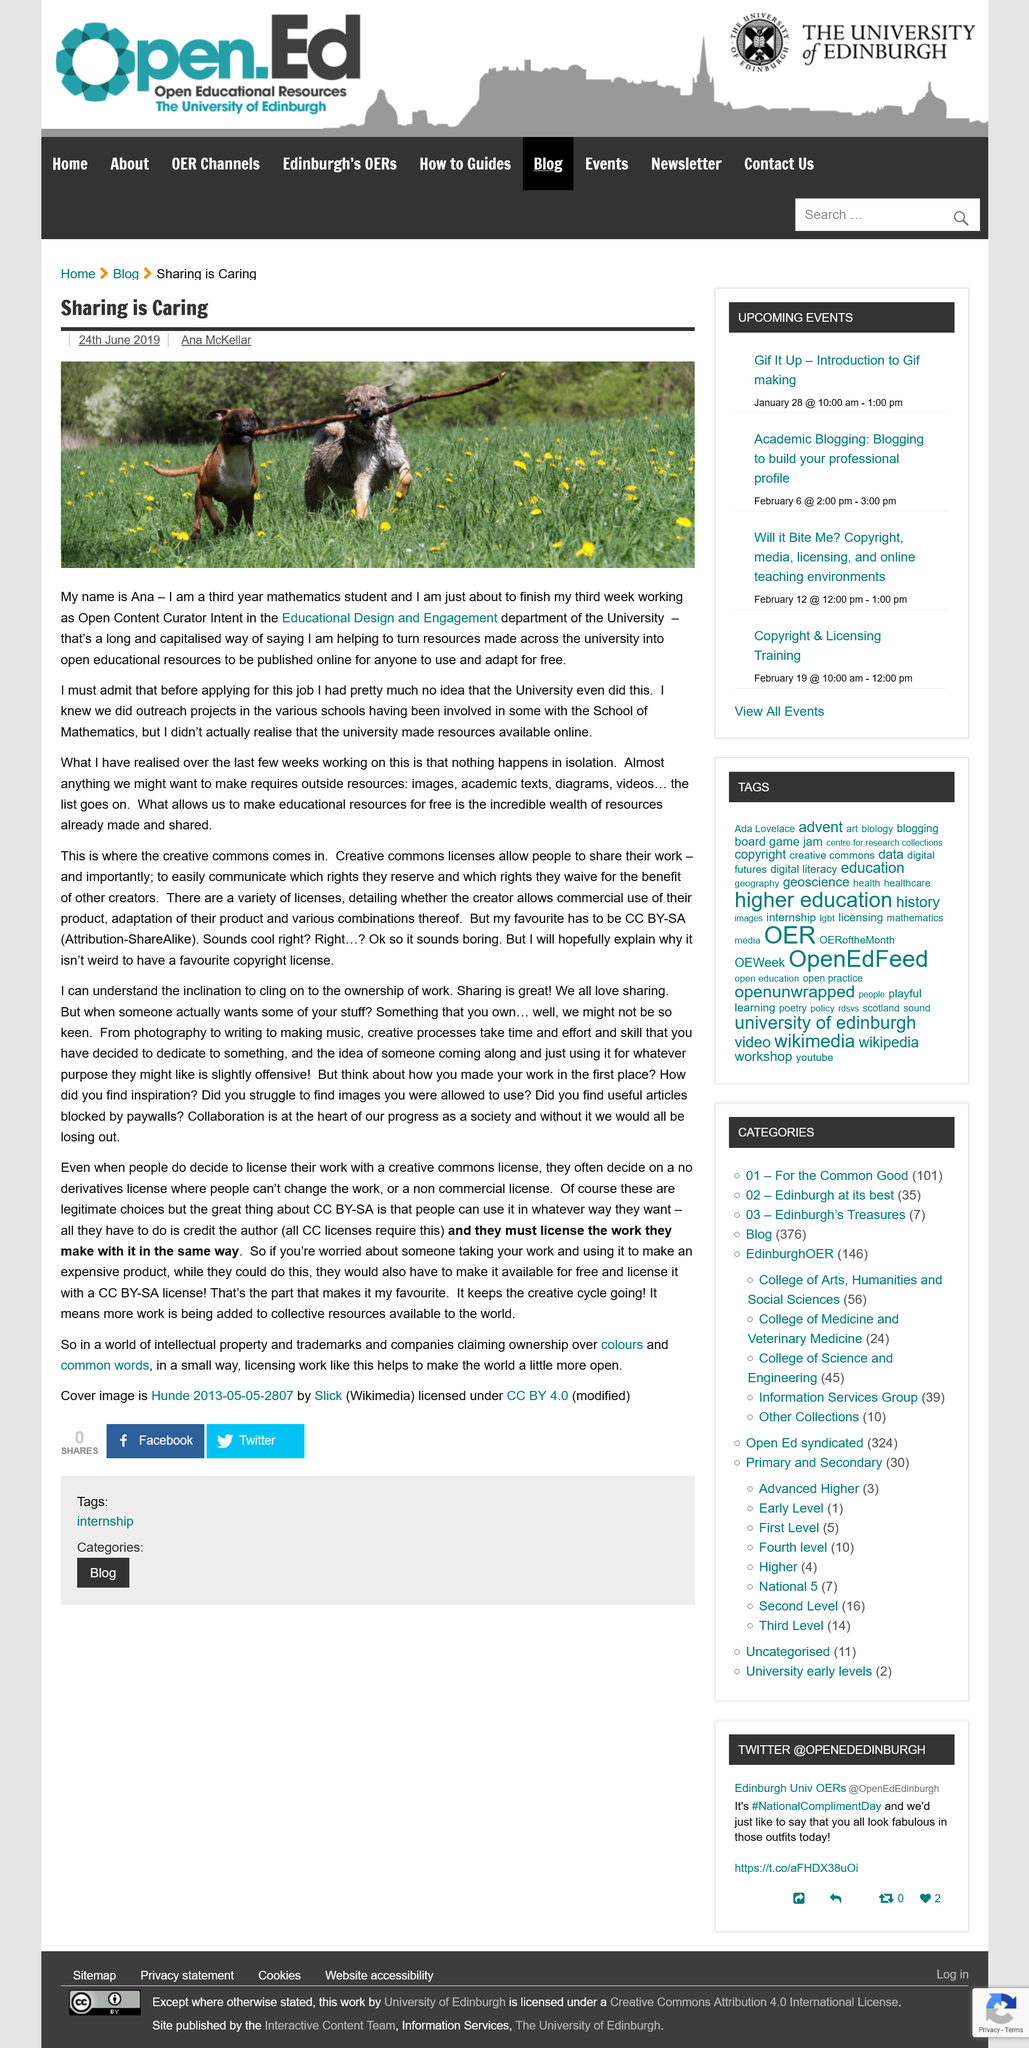Indicate a few pertinent items in this graphic. The article dated 24th June 2019 was authored by Ana McKellar. The date of the article entitled 'Sharing is Caring' is 24th June 2019, as stated in the article itself. Ana McKellar is studying mathematics at university. 